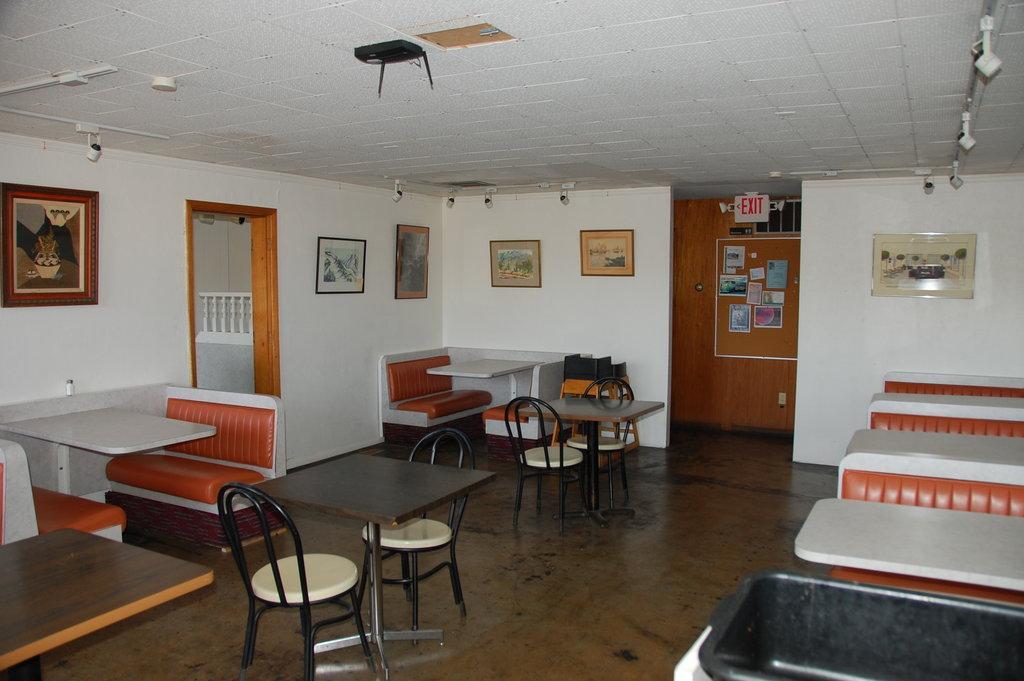How would you summarize this image in a sentence or two? In this picture I can observe tables which are in white and brown color. I can observe some chairs. On the left side there is a door. In the background I can observe some photo frames on the wall. 